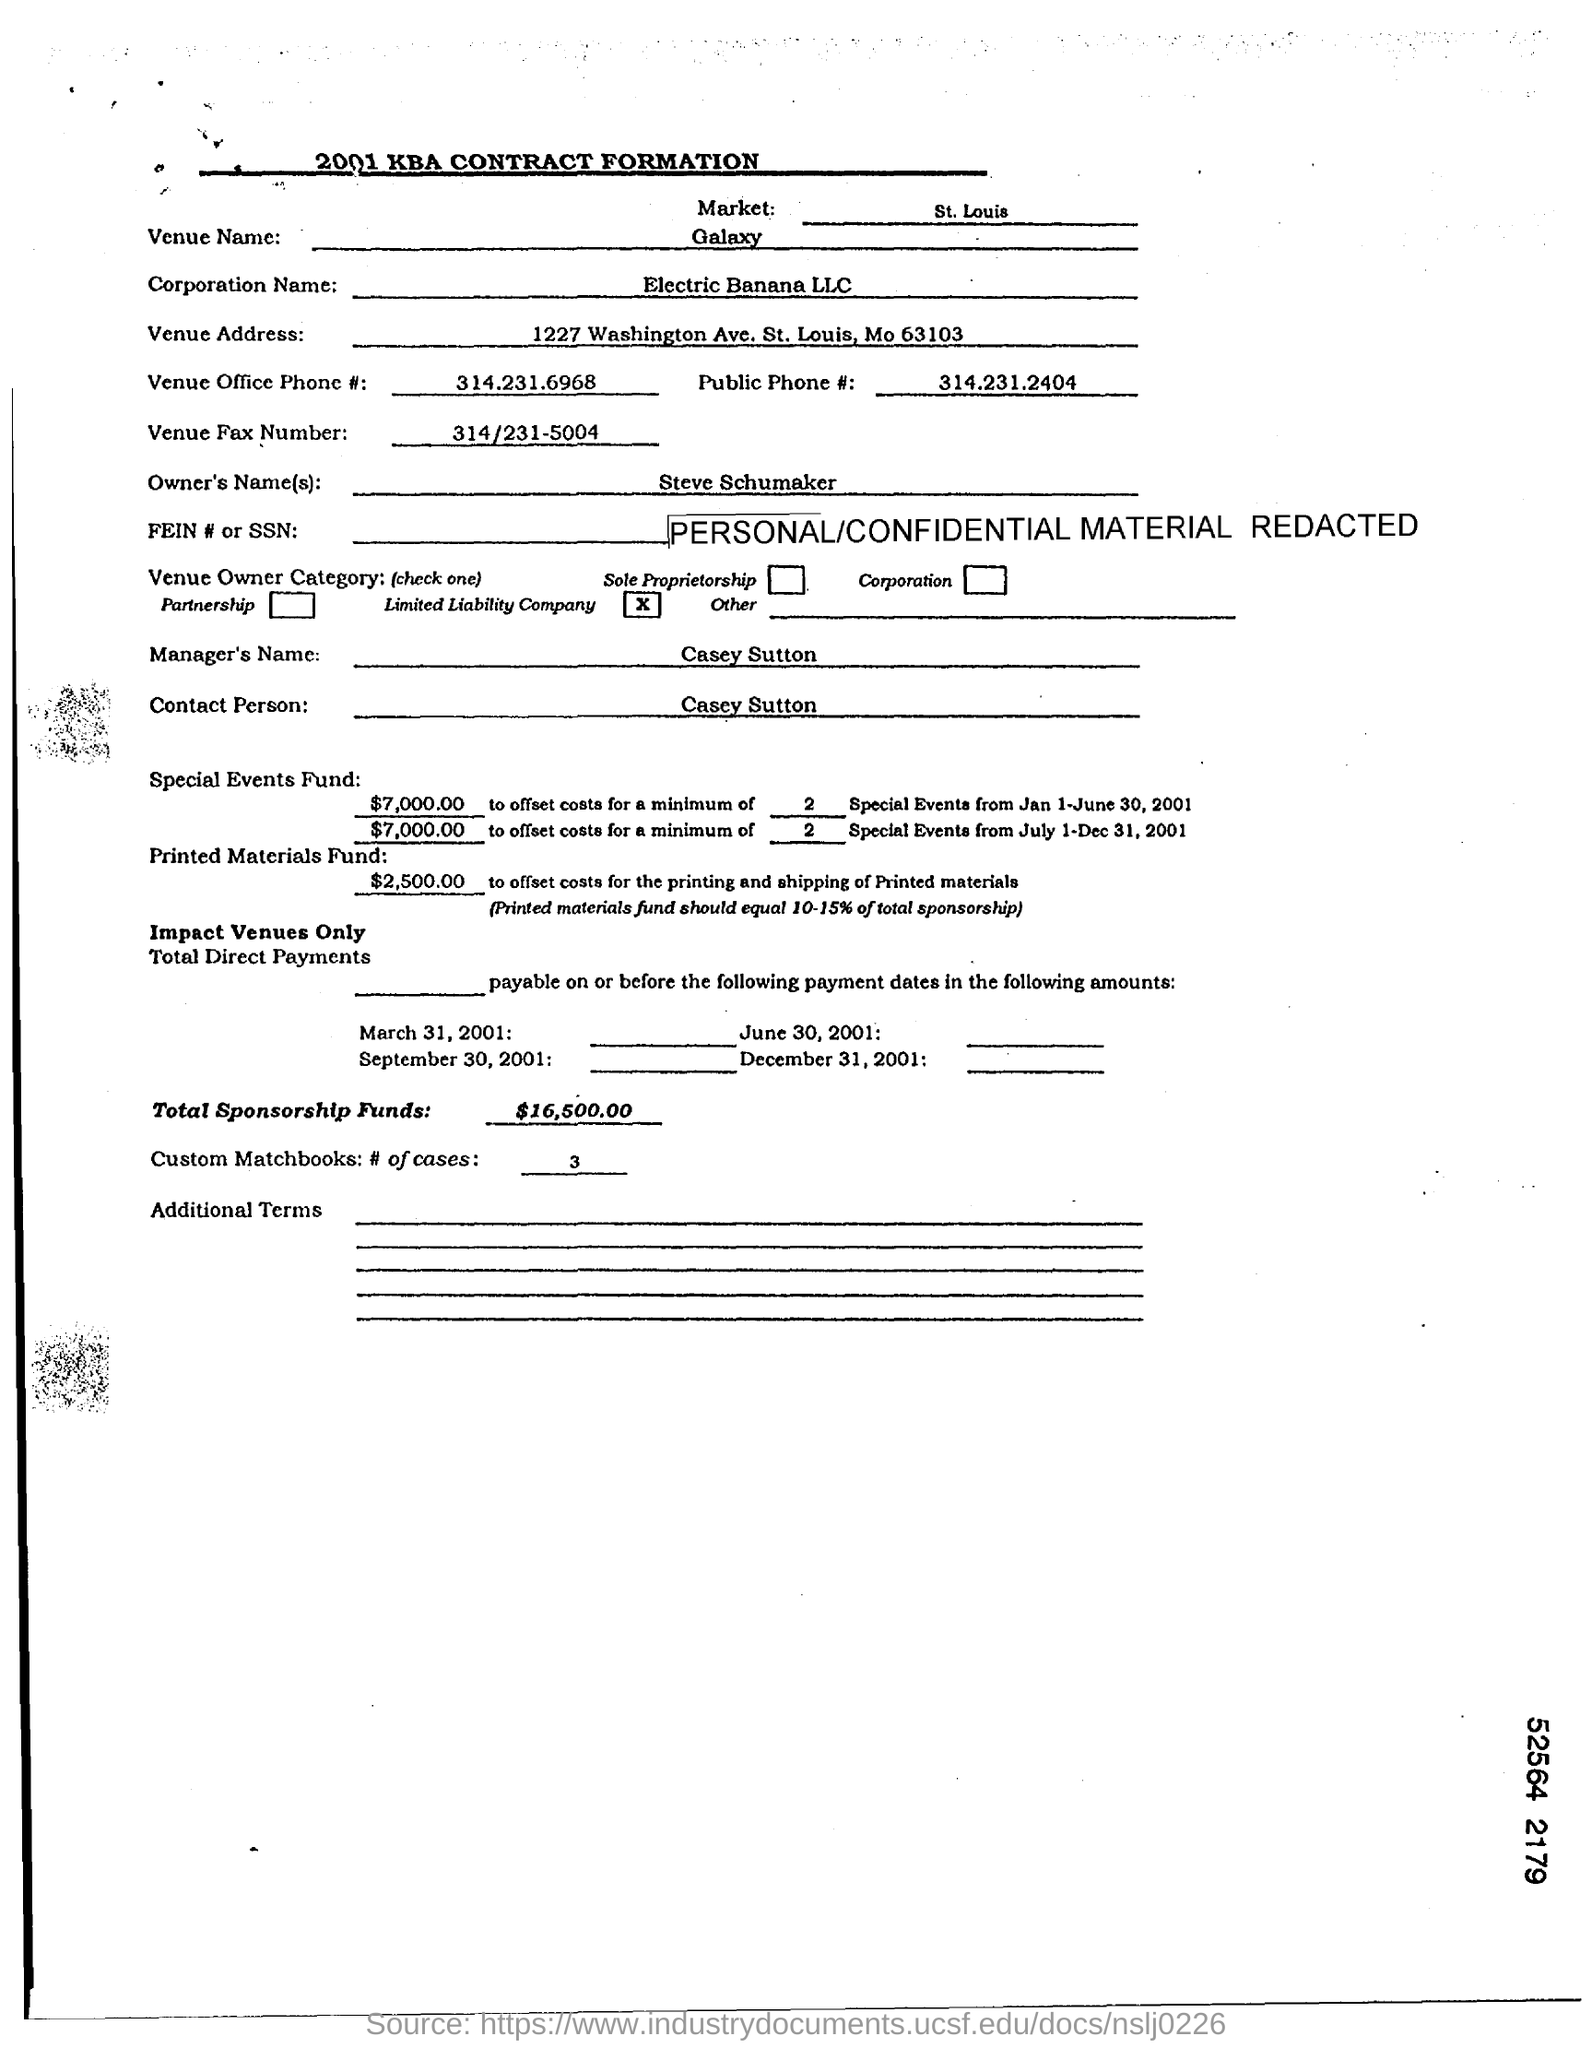What is the Corporation Name?
Keep it short and to the point. Electric Banana LLC. What is the Venue Name?
Give a very brief answer. Galaxy. What is the Venue Office Phone #?
Offer a very short reply. 314.231.6968. What is the Market?
Offer a terse response. St. Louis. What is the Total Sponsorship Funds?
Keep it short and to the point. $16,500.00. What is the Owner's Name given in the document?
Offer a very short reply. Steve Schumaker. 